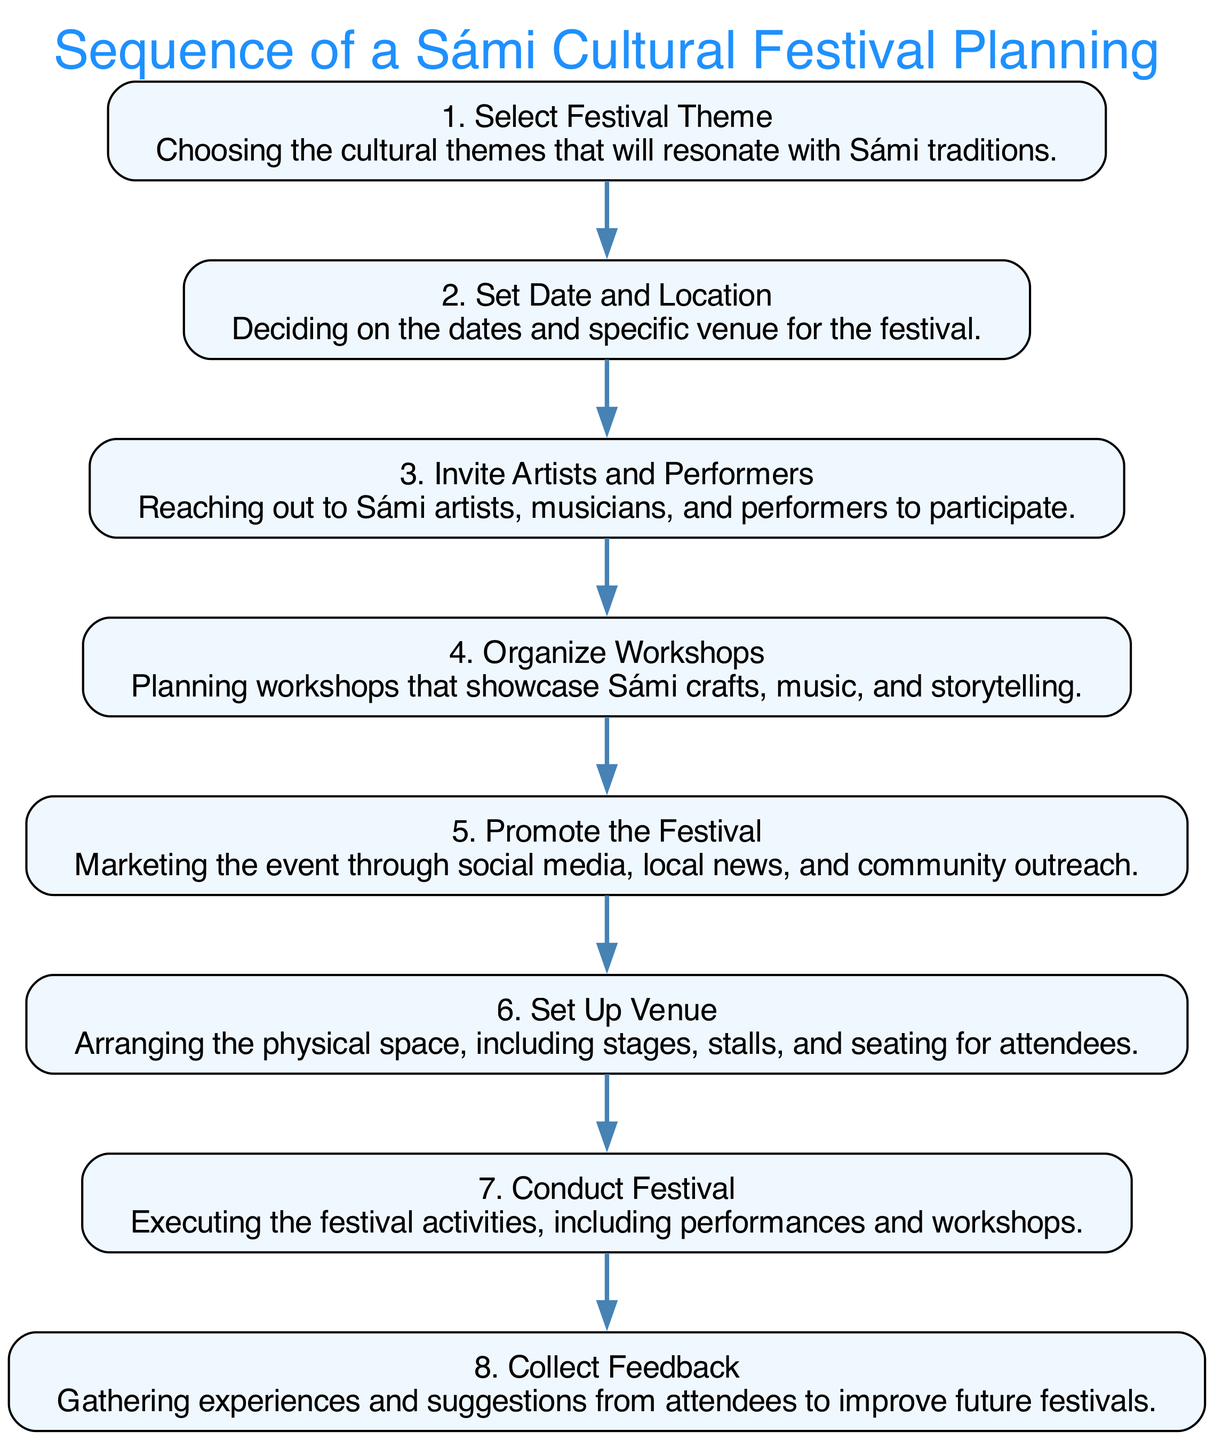What is the first step in the festival planning sequence? The first step is "Select Festival Theme," which is the initial action that sets the context for the entire festival planning process based on Sámi traditions.
Answer: Select Festival Theme How many total steps are in the sequence? There are eight steps in the sequence, as listed in the provided data, indicating a structured progression through the festival planning process.
Answer: 8 What follows after "Set Date and Location"? The step that follows "Set Date and Location" is "Invite Artists and Performers," which indicates the sequential nature of planning after determining the logistical aspects.
Answer: Invite Artists and Performers Which activity involves marketing the event? The activity that involves marketing the event is "Promote the Festival," as it focuses on raising awareness and informing the community about the festival.
Answer: Promote the Festival What is the last step of the sequence? The last step, which completes the festival planning process, is "Collect Feedback," aimed at acquiring insights from attendees for future improvements.
Answer: Collect Feedback How many connections (edges) are in the sequence? There are seven connections or edges in the sequence, as each step is linked to the next step in a linear fashion, forming a complete flow from start to finish.
Answer: 7 Which two steps are directly connected to "Organize Workshops"? The two steps directly connected to "Organize Workshops" are "Invite Artists and Performers" and "Conduct Festival," as they both relate to participation and execution of the festival elements.
Answer: Invite Artists and Performers, Conduct Festival What is the purpose of the "Set Up Venue" step? The purpose of the "Set Up Venue" step is to arrange the physical space for the festival, including necessary infrastructure like stages and seating for attendees.
Answer: To arrange the physical space 